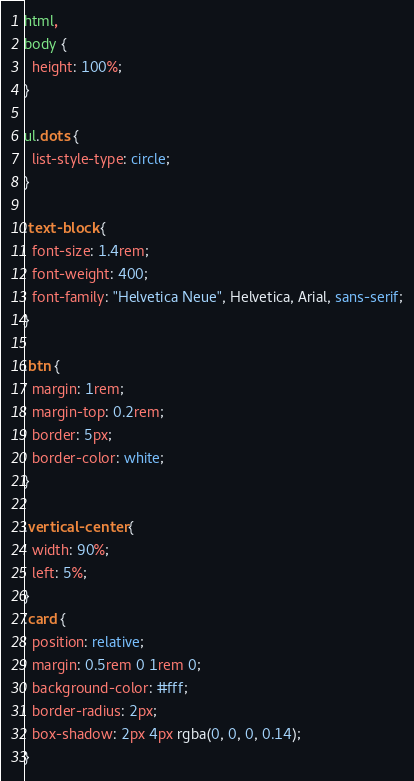<code> <loc_0><loc_0><loc_500><loc_500><_CSS_>html,
body {
  height: 100%;
}

ul.dots {
  list-style-type: circle;
}

.text-block {
  font-size: 1.4rem;
  font-weight: 400;
  font-family: "Helvetica Neue", Helvetica, Arial, sans-serif;
}

.btn {
  margin: 1rem;
  margin-top: 0.2rem;
  border: 5px;
  border-color: white;
}

.vertical-center {
  width: 90%;
  left: 5%;
}
.card {
  position: relative;
  margin: 0.5rem 0 1rem 0;
  background-color: #fff;
  border-radius: 2px;
  box-shadow: 2px 4px rgba(0, 0, 0, 0.14);
}
</code> 